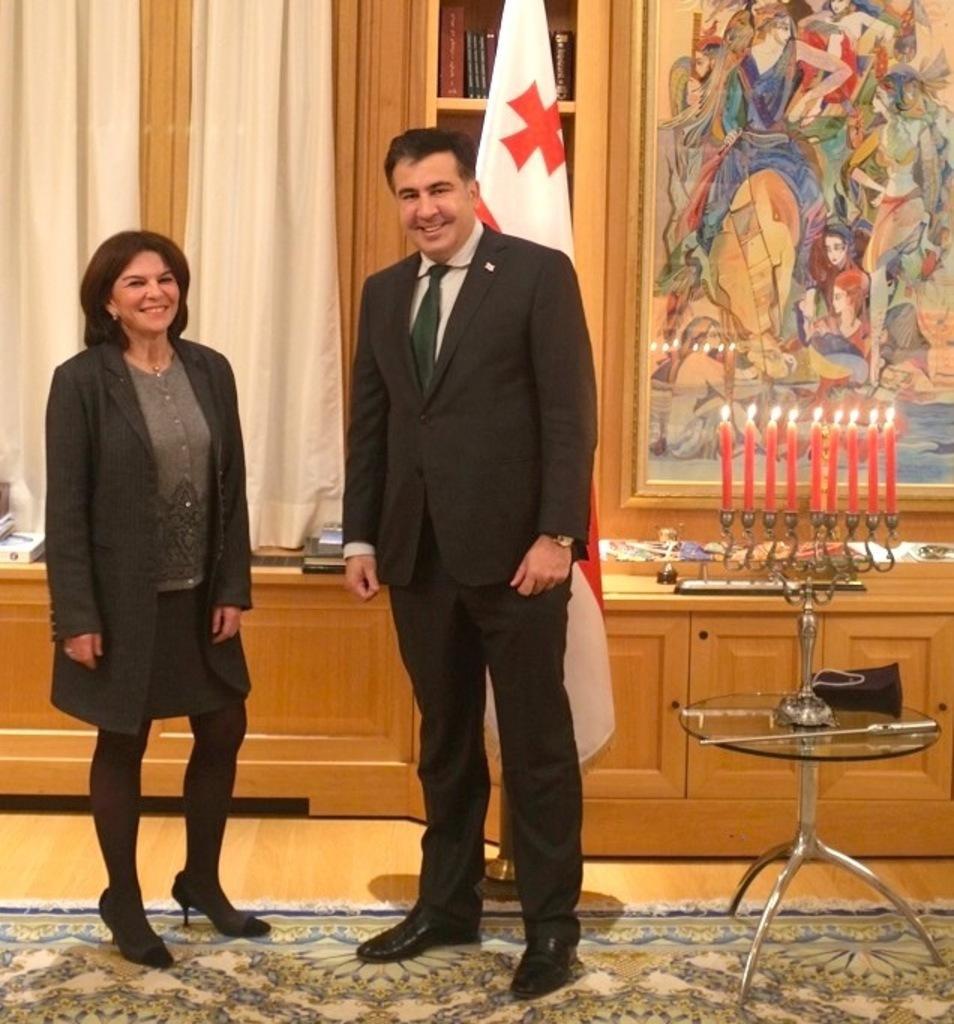Could you give a brief overview of what you see in this image? The two persons are standing and smiling. There is a table on the right side. There is a candle light on a table. There is a cupboard on a table. There is a books on a cupboard. We can see in the background flag,wall,photo frame. 